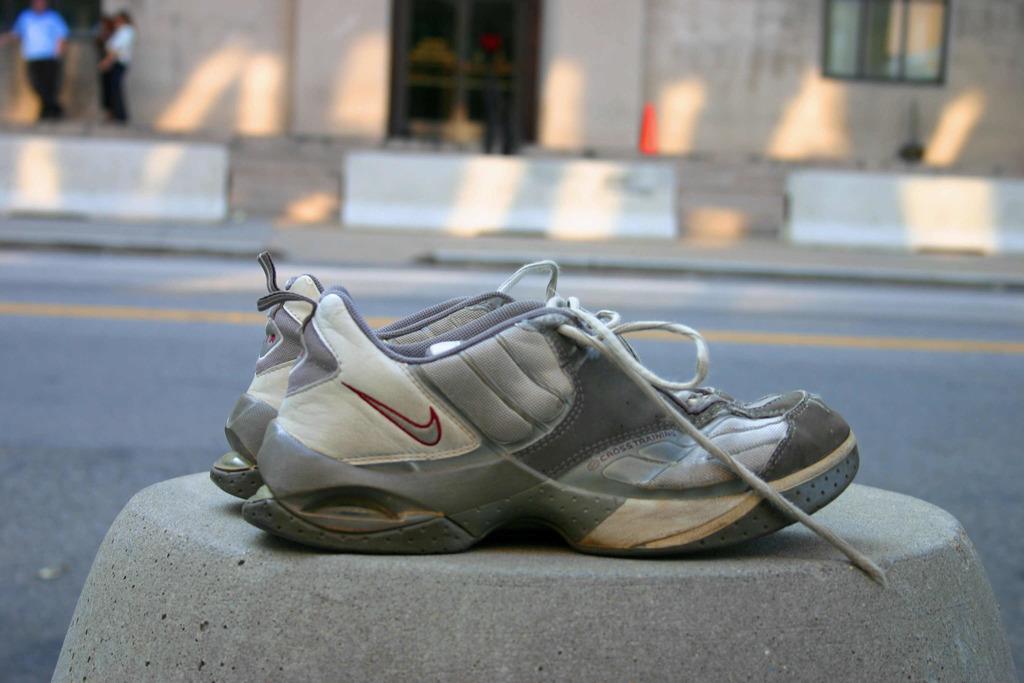Can you describe this image briefly? In this image there are shoes, in the background there is a road and a footpath,on that footpath there are three persons. 